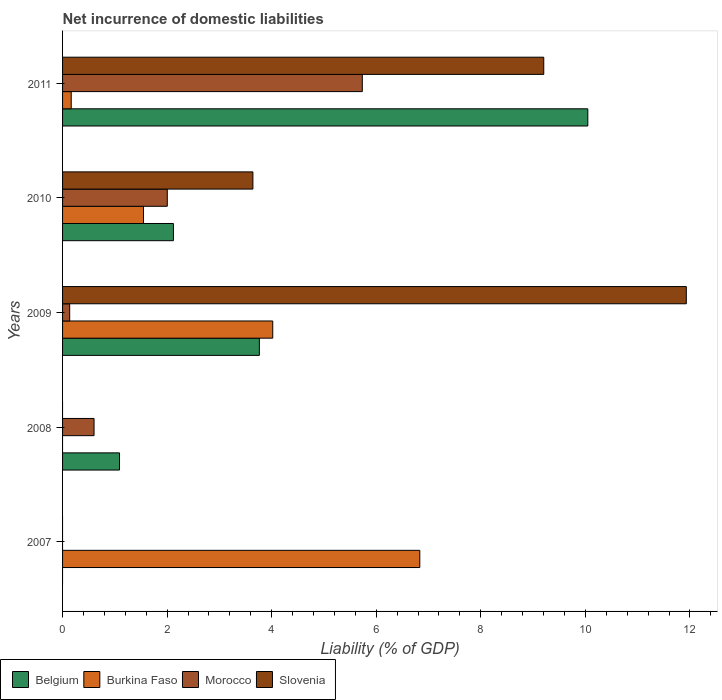How many different coloured bars are there?
Your answer should be very brief. 4. Are the number of bars per tick equal to the number of legend labels?
Your response must be concise. No. How many bars are there on the 3rd tick from the bottom?
Your answer should be compact. 4. What is the net incurrence of domestic liabilities in Burkina Faso in 2007?
Your answer should be very brief. 6.83. Across all years, what is the maximum net incurrence of domestic liabilities in Burkina Faso?
Provide a short and direct response. 6.83. Across all years, what is the minimum net incurrence of domestic liabilities in Slovenia?
Your answer should be very brief. 0. What is the total net incurrence of domestic liabilities in Burkina Faso in the graph?
Keep it short and to the point. 12.57. What is the difference between the net incurrence of domestic liabilities in Burkina Faso in 2010 and that in 2011?
Your answer should be very brief. 1.38. What is the difference between the net incurrence of domestic liabilities in Burkina Faso in 2008 and the net incurrence of domestic liabilities in Morocco in 2007?
Offer a very short reply. 0. What is the average net incurrence of domestic liabilities in Morocco per year?
Ensure brevity in your answer.  1.69. In the year 2009, what is the difference between the net incurrence of domestic liabilities in Belgium and net incurrence of domestic liabilities in Burkina Faso?
Keep it short and to the point. -0.26. In how many years, is the net incurrence of domestic liabilities in Belgium greater than 8.8 %?
Make the answer very short. 1. What is the ratio of the net incurrence of domestic liabilities in Belgium in 2009 to that in 2010?
Your response must be concise. 1.78. Is the net incurrence of domestic liabilities in Belgium in 2009 less than that in 2011?
Your answer should be very brief. Yes. What is the difference between the highest and the second highest net incurrence of domestic liabilities in Slovenia?
Provide a succinct answer. 2.73. What is the difference between the highest and the lowest net incurrence of domestic liabilities in Morocco?
Offer a very short reply. 5.73. In how many years, is the net incurrence of domestic liabilities in Morocco greater than the average net incurrence of domestic liabilities in Morocco taken over all years?
Provide a short and direct response. 2. Is the sum of the net incurrence of domestic liabilities in Burkina Faso in 2007 and 2010 greater than the maximum net incurrence of domestic liabilities in Slovenia across all years?
Your answer should be very brief. No. How many bars are there?
Make the answer very short. 15. How many years are there in the graph?
Offer a terse response. 5. What is the difference between two consecutive major ticks on the X-axis?
Provide a succinct answer. 2. Does the graph contain any zero values?
Your answer should be compact. Yes. Where does the legend appear in the graph?
Provide a succinct answer. Bottom left. How many legend labels are there?
Your answer should be compact. 4. How are the legend labels stacked?
Ensure brevity in your answer.  Horizontal. What is the title of the graph?
Make the answer very short. Net incurrence of domestic liabilities. What is the label or title of the X-axis?
Your answer should be very brief. Liability (% of GDP). What is the label or title of the Y-axis?
Give a very brief answer. Years. What is the Liability (% of GDP) in Belgium in 2007?
Your answer should be compact. 0. What is the Liability (% of GDP) of Burkina Faso in 2007?
Keep it short and to the point. 6.83. What is the Liability (% of GDP) in Belgium in 2008?
Offer a terse response. 1.09. What is the Liability (% of GDP) of Burkina Faso in 2008?
Your answer should be compact. 0. What is the Liability (% of GDP) in Morocco in 2008?
Provide a short and direct response. 0.6. What is the Liability (% of GDP) of Slovenia in 2008?
Your answer should be compact. 0. What is the Liability (% of GDP) in Belgium in 2009?
Keep it short and to the point. 3.76. What is the Liability (% of GDP) of Burkina Faso in 2009?
Keep it short and to the point. 4.02. What is the Liability (% of GDP) in Morocco in 2009?
Make the answer very short. 0.14. What is the Liability (% of GDP) in Slovenia in 2009?
Offer a very short reply. 11.93. What is the Liability (% of GDP) of Belgium in 2010?
Give a very brief answer. 2.12. What is the Liability (% of GDP) in Burkina Faso in 2010?
Offer a very short reply. 1.55. What is the Liability (% of GDP) in Morocco in 2010?
Offer a terse response. 2. What is the Liability (% of GDP) of Slovenia in 2010?
Provide a succinct answer. 3.64. What is the Liability (% of GDP) in Belgium in 2011?
Keep it short and to the point. 10.05. What is the Liability (% of GDP) of Burkina Faso in 2011?
Your answer should be compact. 0.17. What is the Liability (% of GDP) in Morocco in 2011?
Provide a short and direct response. 5.73. What is the Liability (% of GDP) of Slovenia in 2011?
Provide a succinct answer. 9.2. Across all years, what is the maximum Liability (% of GDP) in Belgium?
Provide a short and direct response. 10.05. Across all years, what is the maximum Liability (% of GDP) of Burkina Faso?
Your answer should be very brief. 6.83. Across all years, what is the maximum Liability (% of GDP) in Morocco?
Your answer should be compact. 5.73. Across all years, what is the maximum Liability (% of GDP) in Slovenia?
Ensure brevity in your answer.  11.93. Across all years, what is the minimum Liability (% of GDP) in Belgium?
Your answer should be compact. 0. Across all years, what is the minimum Liability (% of GDP) of Burkina Faso?
Provide a short and direct response. 0. Across all years, what is the minimum Liability (% of GDP) in Slovenia?
Provide a short and direct response. 0. What is the total Liability (% of GDP) in Belgium in the graph?
Offer a terse response. 17.02. What is the total Liability (% of GDP) in Burkina Faso in the graph?
Offer a very short reply. 12.57. What is the total Liability (% of GDP) in Morocco in the graph?
Your response must be concise. 8.47. What is the total Liability (% of GDP) of Slovenia in the graph?
Make the answer very short. 24.77. What is the difference between the Liability (% of GDP) in Burkina Faso in 2007 and that in 2009?
Offer a very short reply. 2.81. What is the difference between the Liability (% of GDP) of Burkina Faso in 2007 and that in 2010?
Offer a very short reply. 5.29. What is the difference between the Liability (% of GDP) of Burkina Faso in 2007 and that in 2011?
Offer a very short reply. 6.67. What is the difference between the Liability (% of GDP) in Belgium in 2008 and that in 2009?
Your answer should be compact. -2.67. What is the difference between the Liability (% of GDP) of Morocco in 2008 and that in 2009?
Ensure brevity in your answer.  0.47. What is the difference between the Liability (% of GDP) in Belgium in 2008 and that in 2010?
Offer a terse response. -1.03. What is the difference between the Liability (% of GDP) of Morocco in 2008 and that in 2010?
Keep it short and to the point. -1.4. What is the difference between the Liability (% of GDP) of Belgium in 2008 and that in 2011?
Your response must be concise. -8.96. What is the difference between the Liability (% of GDP) in Morocco in 2008 and that in 2011?
Your response must be concise. -5.13. What is the difference between the Liability (% of GDP) in Belgium in 2009 and that in 2010?
Keep it short and to the point. 1.64. What is the difference between the Liability (% of GDP) in Burkina Faso in 2009 and that in 2010?
Provide a succinct answer. 2.47. What is the difference between the Liability (% of GDP) in Morocco in 2009 and that in 2010?
Give a very brief answer. -1.87. What is the difference between the Liability (% of GDP) in Slovenia in 2009 and that in 2010?
Provide a short and direct response. 8.29. What is the difference between the Liability (% of GDP) of Belgium in 2009 and that in 2011?
Offer a very short reply. -6.28. What is the difference between the Liability (% of GDP) in Burkina Faso in 2009 and that in 2011?
Provide a short and direct response. 3.85. What is the difference between the Liability (% of GDP) in Morocco in 2009 and that in 2011?
Give a very brief answer. -5.6. What is the difference between the Liability (% of GDP) of Slovenia in 2009 and that in 2011?
Keep it short and to the point. 2.73. What is the difference between the Liability (% of GDP) of Belgium in 2010 and that in 2011?
Provide a succinct answer. -7.93. What is the difference between the Liability (% of GDP) in Burkina Faso in 2010 and that in 2011?
Give a very brief answer. 1.38. What is the difference between the Liability (% of GDP) in Morocco in 2010 and that in 2011?
Provide a succinct answer. -3.73. What is the difference between the Liability (% of GDP) in Slovenia in 2010 and that in 2011?
Make the answer very short. -5.56. What is the difference between the Liability (% of GDP) in Burkina Faso in 2007 and the Liability (% of GDP) in Morocco in 2008?
Your response must be concise. 6.23. What is the difference between the Liability (% of GDP) of Burkina Faso in 2007 and the Liability (% of GDP) of Morocco in 2009?
Offer a terse response. 6.7. What is the difference between the Liability (% of GDP) of Burkina Faso in 2007 and the Liability (% of GDP) of Slovenia in 2009?
Offer a very short reply. -5.1. What is the difference between the Liability (% of GDP) of Burkina Faso in 2007 and the Liability (% of GDP) of Morocco in 2010?
Your response must be concise. 4.83. What is the difference between the Liability (% of GDP) in Burkina Faso in 2007 and the Liability (% of GDP) in Slovenia in 2010?
Provide a succinct answer. 3.19. What is the difference between the Liability (% of GDP) in Burkina Faso in 2007 and the Liability (% of GDP) in Morocco in 2011?
Your response must be concise. 1.1. What is the difference between the Liability (% of GDP) of Burkina Faso in 2007 and the Liability (% of GDP) of Slovenia in 2011?
Your response must be concise. -2.37. What is the difference between the Liability (% of GDP) of Belgium in 2008 and the Liability (% of GDP) of Burkina Faso in 2009?
Offer a terse response. -2.93. What is the difference between the Liability (% of GDP) in Belgium in 2008 and the Liability (% of GDP) in Morocco in 2009?
Offer a very short reply. 0.95. What is the difference between the Liability (% of GDP) in Belgium in 2008 and the Liability (% of GDP) in Slovenia in 2009?
Give a very brief answer. -10.84. What is the difference between the Liability (% of GDP) in Morocco in 2008 and the Liability (% of GDP) in Slovenia in 2009?
Your answer should be compact. -11.33. What is the difference between the Liability (% of GDP) of Belgium in 2008 and the Liability (% of GDP) of Burkina Faso in 2010?
Your answer should be compact. -0.46. What is the difference between the Liability (% of GDP) of Belgium in 2008 and the Liability (% of GDP) of Morocco in 2010?
Offer a very short reply. -0.91. What is the difference between the Liability (% of GDP) of Belgium in 2008 and the Liability (% of GDP) of Slovenia in 2010?
Your answer should be very brief. -2.55. What is the difference between the Liability (% of GDP) of Morocco in 2008 and the Liability (% of GDP) of Slovenia in 2010?
Ensure brevity in your answer.  -3.04. What is the difference between the Liability (% of GDP) in Belgium in 2008 and the Liability (% of GDP) in Burkina Faso in 2011?
Your answer should be very brief. 0.92. What is the difference between the Liability (% of GDP) in Belgium in 2008 and the Liability (% of GDP) in Morocco in 2011?
Offer a terse response. -4.64. What is the difference between the Liability (% of GDP) of Belgium in 2008 and the Liability (% of GDP) of Slovenia in 2011?
Provide a succinct answer. -8.11. What is the difference between the Liability (% of GDP) of Morocco in 2008 and the Liability (% of GDP) of Slovenia in 2011?
Make the answer very short. -8.6. What is the difference between the Liability (% of GDP) of Belgium in 2009 and the Liability (% of GDP) of Burkina Faso in 2010?
Ensure brevity in your answer.  2.22. What is the difference between the Liability (% of GDP) of Belgium in 2009 and the Liability (% of GDP) of Morocco in 2010?
Offer a terse response. 1.76. What is the difference between the Liability (% of GDP) in Belgium in 2009 and the Liability (% of GDP) in Slovenia in 2010?
Provide a short and direct response. 0.12. What is the difference between the Liability (% of GDP) of Burkina Faso in 2009 and the Liability (% of GDP) of Morocco in 2010?
Your answer should be compact. 2.02. What is the difference between the Liability (% of GDP) of Burkina Faso in 2009 and the Liability (% of GDP) of Slovenia in 2010?
Your answer should be compact. 0.38. What is the difference between the Liability (% of GDP) of Morocco in 2009 and the Liability (% of GDP) of Slovenia in 2010?
Provide a succinct answer. -3.5. What is the difference between the Liability (% of GDP) in Belgium in 2009 and the Liability (% of GDP) in Burkina Faso in 2011?
Your response must be concise. 3.6. What is the difference between the Liability (% of GDP) in Belgium in 2009 and the Liability (% of GDP) in Morocco in 2011?
Ensure brevity in your answer.  -1.97. What is the difference between the Liability (% of GDP) of Belgium in 2009 and the Liability (% of GDP) of Slovenia in 2011?
Offer a terse response. -5.44. What is the difference between the Liability (% of GDP) of Burkina Faso in 2009 and the Liability (% of GDP) of Morocco in 2011?
Provide a succinct answer. -1.71. What is the difference between the Liability (% of GDP) of Burkina Faso in 2009 and the Liability (% of GDP) of Slovenia in 2011?
Provide a short and direct response. -5.18. What is the difference between the Liability (% of GDP) of Morocco in 2009 and the Liability (% of GDP) of Slovenia in 2011?
Your response must be concise. -9.07. What is the difference between the Liability (% of GDP) in Belgium in 2010 and the Liability (% of GDP) in Burkina Faso in 2011?
Provide a short and direct response. 1.95. What is the difference between the Liability (% of GDP) of Belgium in 2010 and the Liability (% of GDP) of Morocco in 2011?
Your answer should be very brief. -3.61. What is the difference between the Liability (% of GDP) in Belgium in 2010 and the Liability (% of GDP) in Slovenia in 2011?
Offer a terse response. -7.08. What is the difference between the Liability (% of GDP) in Burkina Faso in 2010 and the Liability (% of GDP) in Morocco in 2011?
Ensure brevity in your answer.  -4.19. What is the difference between the Liability (% of GDP) of Burkina Faso in 2010 and the Liability (% of GDP) of Slovenia in 2011?
Offer a terse response. -7.66. What is the difference between the Liability (% of GDP) of Morocco in 2010 and the Liability (% of GDP) of Slovenia in 2011?
Make the answer very short. -7.2. What is the average Liability (% of GDP) in Belgium per year?
Ensure brevity in your answer.  3.4. What is the average Liability (% of GDP) of Burkina Faso per year?
Provide a short and direct response. 2.51. What is the average Liability (% of GDP) of Morocco per year?
Keep it short and to the point. 1.69. What is the average Liability (% of GDP) of Slovenia per year?
Make the answer very short. 4.96. In the year 2008, what is the difference between the Liability (% of GDP) in Belgium and Liability (% of GDP) in Morocco?
Offer a very short reply. 0.49. In the year 2009, what is the difference between the Liability (% of GDP) of Belgium and Liability (% of GDP) of Burkina Faso?
Provide a succinct answer. -0.26. In the year 2009, what is the difference between the Liability (% of GDP) of Belgium and Liability (% of GDP) of Morocco?
Keep it short and to the point. 3.63. In the year 2009, what is the difference between the Liability (% of GDP) in Belgium and Liability (% of GDP) in Slovenia?
Offer a terse response. -8.17. In the year 2009, what is the difference between the Liability (% of GDP) in Burkina Faso and Liability (% of GDP) in Morocco?
Provide a succinct answer. 3.88. In the year 2009, what is the difference between the Liability (% of GDP) in Burkina Faso and Liability (% of GDP) in Slovenia?
Offer a terse response. -7.91. In the year 2009, what is the difference between the Liability (% of GDP) in Morocco and Liability (% of GDP) in Slovenia?
Provide a short and direct response. -11.79. In the year 2010, what is the difference between the Liability (% of GDP) in Belgium and Liability (% of GDP) in Burkina Faso?
Provide a succinct answer. 0.57. In the year 2010, what is the difference between the Liability (% of GDP) in Belgium and Liability (% of GDP) in Morocco?
Ensure brevity in your answer.  0.12. In the year 2010, what is the difference between the Liability (% of GDP) of Belgium and Liability (% of GDP) of Slovenia?
Offer a very short reply. -1.52. In the year 2010, what is the difference between the Liability (% of GDP) in Burkina Faso and Liability (% of GDP) in Morocco?
Provide a succinct answer. -0.46. In the year 2010, what is the difference between the Liability (% of GDP) of Burkina Faso and Liability (% of GDP) of Slovenia?
Provide a succinct answer. -2.09. In the year 2010, what is the difference between the Liability (% of GDP) of Morocco and Liability (% of GDP) of Slovenia?
Your answer should be compact. -1.64. In the year 2011, what is the difference between the Liability (% of GDP) of Belgium and Liability (% of GDP) of Burkina Faso?
Provide a succinct answer. 9.88. In the year 2011, what is the difference between the Liability (% of GDP) in Belgium and Liability (% of GDP) in Morocco?
Ensure brevity in your answer.  4.31. In the year 2011, what is the difference between the Liability (% of GDP) of Belgium and Liability (% of GDP) of Slovenia?
Ensure brevity in your answer.  0.84. In the year 2011, what is the difference between the Liability (% of GDP) of Burkina Faso and Liability (% of GDP) of Morocco?
Your answer should be compact. -5.57. In the year 2011, what is the difference between the Liability (% of GDP) of Burkina Faso and Liability (% of GDP) of Slovenia?
Ensure brevity in your answer.  -9.04. In the year 2011, what is the difference between the Liability (% of GDP) of Morocco and Liability (% of GDP) of Slovenia?
Your answer should be compact. -3.47. What is the ratio of the Liability (% of GDP) of Burkina Faso in 2007 to that in 2009?
Offer a very short reply. 1.7. What is the ratio of the Liability (% of GDP) of Burkina Faso in 2007 to that in 2010?
Provide a short and direct response. 4.41. What is the ratio of the Liability (% of GDP) in Burkina Faso in 2007 to that in 2011?
Keep it short and to the point. 41.3. What is the ratio of the Liability (% of GDP) of Belgium in 2008 to that in 2009?
Provide a short and direct response. 0.29. What is the ratio of the Liability (% of GDP) in Morocco in 2008 to that in 2009?
Your response must be concise. 4.42. What is the ratio of the Liability (% of GDP) in Belgium in 2008 to that in 2010?
Provide a succinct answer. 0.51. What is the ratio of the Liability (% of GDP) in Morocco in 2008 to that in 2010?
Offer a terse response. 0.3. What is the ratio of the Liability (% of GDP) in Belgium in 2008 to that in 2011?
Your answer should be very brief. 0.11. What is the ratio of the Liability (% of GDP) of Morocco in 2008 to that in 2011?
Your answer should be compact. 0.1. What is the ratio of the Liability (% of GDP) in Belgium in 2009 to that in 2010?
Ensure brevity in your answer.  1.78. What is the ratio of the Liability (% of GDP) of Burkina Faso in 2009 to that in 2010?
Your answer should be compact. 2.6. What is the ratio of the Liability (% of GDP) of Morocco in 2009 to that in 2010?
Provide a short and direct response. 0.07. What is the ratio of the Liability (% of GDP) of Slovenia in 2009 to that in 2010?
Your response must be concise. 3.28. What is the ratio of the Liability (% of GDP) in Belgium in 2009 to that in 2011?
Your answer should be very brief. 0.37. What is the ratio of the Liability (% of GDP) of Burkina Faso in 2009 to that in 2011?
Your answer should be compact. 24.3. What is the ratio of the Liability (% of GDP) of Morocco in 2009 to that in 2011?
Offer a terse response. 0.02. What is the ratio of the Liability (% of GDP) in Slovenia in 2009 to that in 2011?
Make the answer very short. 1.3. What is the ratio of the Liability (% of GDP) in Belgium in 2010 to that in 2011?
Offer a very short reply. 0.21. What is the ratio of the Liability (% of GDP) in Burkina Faso in 2010 to that in 2011?
Make the answer very short. 9.36. What is the ratio of the Liability (% of GDP) in Morocco in 2010 to that in 2011?
Give a very brief answer. 0.35. What is the ratio of the Liability (% of GDP) in Slovenia in 2010 to that in 2011?
Make the answer very short. 0.4. What is the difference between the highest and the second highest Liability (% of GDP) in Belgium?
Ensure brevity in your answer.  6.28. What is the difference between the highest and the second highest Liability (% of GDP) in Burkina Faso?
Your answer should be compact. 2.81. What is the difference between the highest and the second highest Liability (% of GDP) in Morocco?
Offer a very short reply. 3.73. What is the difference between the highest and the second highest Liability (% of GDP) in Slovenia?
Give a very brief answer. 2.73. What is the difference between the highest and the lowest Liability (% of GDP) in Belgium?
Keep it short and to the point. 10.05. What is the difference between the highest and the lowest Liability (% of GDP) in Burkina Faso?
Give a very brief answer. 6.83. What is the difference between the highest and the lowest Liability (% of GDP) in Morocco?
Provide a succinct answer. 5.73. What is the difference between the highest and the lowest Liability (% of GDP) in Slovenia?
Your answer should be compact. 11.93. 